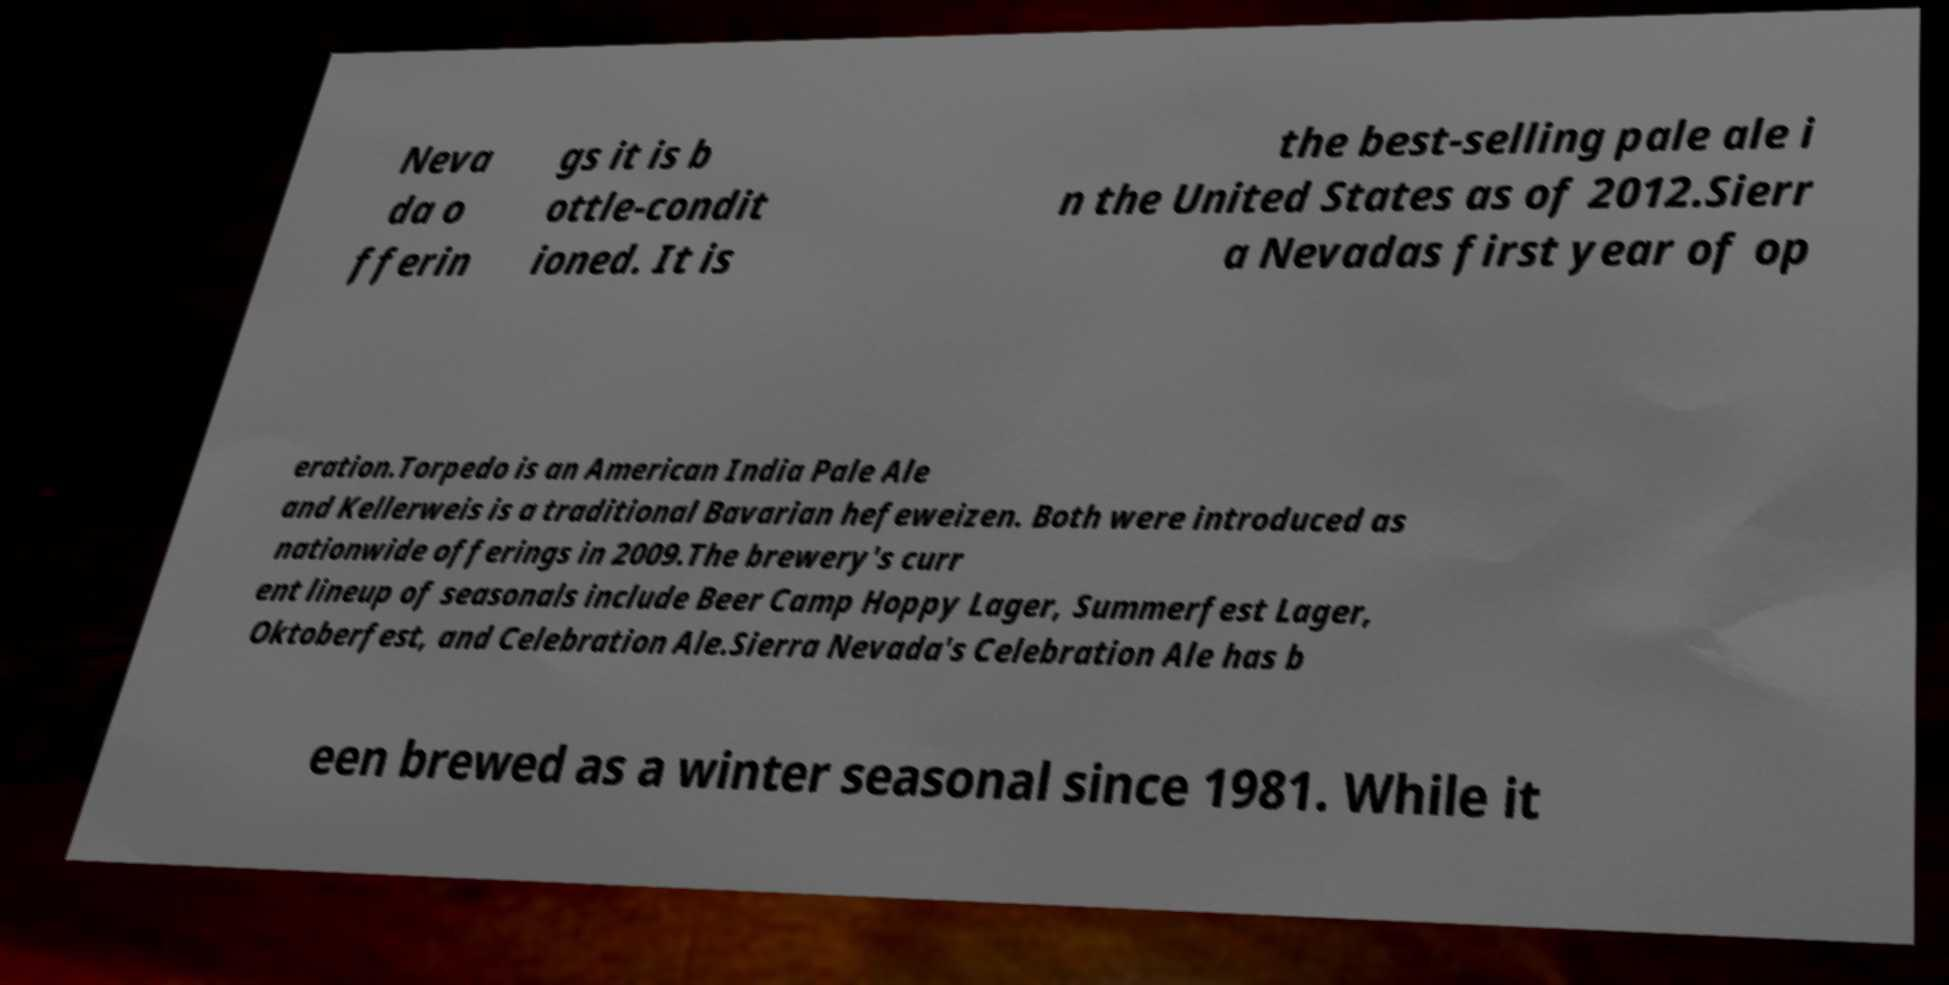Could you extract and type out the text from this image? Neva da o fferin gs it is b ottle-condit ioned. It is the best-selling pale ale i n the United States as of 2012.Sierr a Nevadas first year of op eration.Torpedo is an American India Pale Ale and Kellerweis is a traditional Bavarian hefeweizen. Both were introduced as nationwide offerings in 2009.The brewery's curr ent lineup of seasonals include Beer Camp Hoppy Lager, Summerfest Lager, Oktoberfest, and Celebration Ale.Sierra Nevada's Celebration Ale has b een brewed as a winter seasonal since 1981. While it 